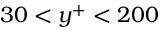Convert formula to latex. <formula><loc_0><loc_0><loc_500><loc_500>3 0 < y ^ { + } < 2 0 0</formula> 